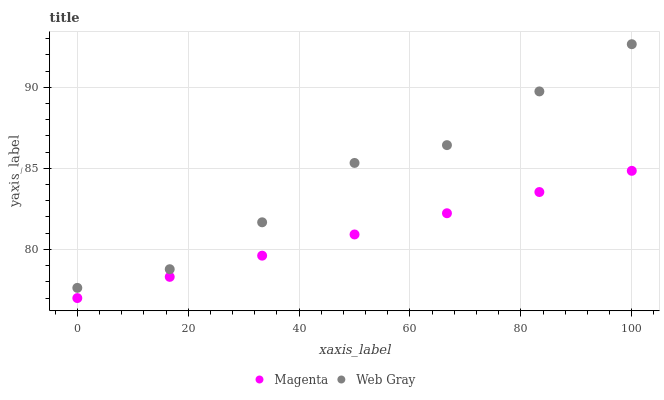Does Magenta have the minimum area under the curve?
Answer yes or no. Yes. Does Web Gray have the maximum area under the curve?
Answer yes or no. Yes. Does Web Gray have the minimum area under the curve?
Answer yes or no. No. Is Magenta the smoothest?
Answer yes or no. Yes. Is Web Gray the roughest?
Answer yes or no. Yes. Is Web Gray the smoothest?
Answer yes or no. No. Does Magenta have the lowest value?
Answer yes or no. Yes. Does Web Gray have the lowest value?
Answer yes or no. No. Does Web Gray have the highest value?
Answer yes or no. Yes. Is Magenta less than Web Gray?
Answer yes or no. Yes. Is Web Gray greater than Magenta?
Answer yes or no. Yes. Does Magenta intersect Web Gray?
Answer yes or no. No. 